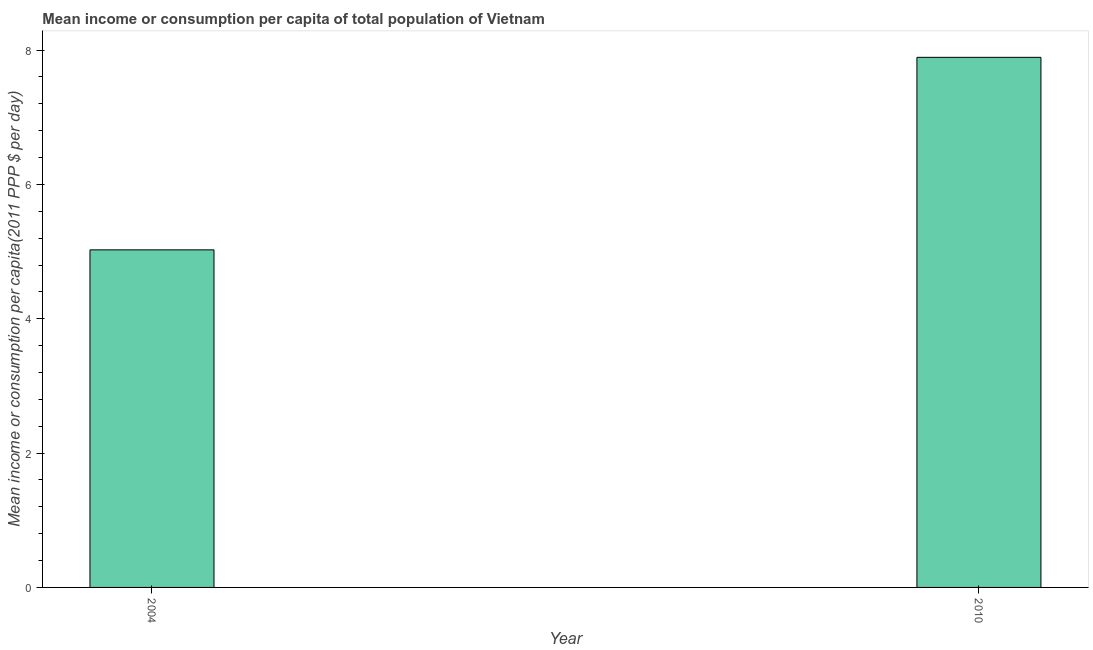What is the title of the graph?
Provide a succinct answer. Mean income or consumption per capita of total population of Vietnam. What is the label or title of the X-axis?
Offer a terse response. Year. What is the label or title of the Y-axis?
Your answer should be very brief. Mean income or consumption per capita(2011 PPP $ per day). What is the mean income or consumption in 2010?
Keep it short and to the point. 7.89. Across all years, what is the maximum mean income or consumption?
Ensure brevity in your answer.  7.89. Across all years, what is the minimum mean income or consumption?
Offer a terse response. 5.03. In which year was the mean income or consumption minimum?
Your answer should be very brief. 2004. What is the sum of the mean income or consumption?
Provide a succinct answer. 12.92. What is the difference between the mean income or consumption in 2004 and 2010?
Your response must be concise. -2.87. What is the average mean income or consumption per year?
Offer a terse response. 6.46. What is the median mean income or consumption?
Keep it short and to the point. 6.46. What is the ratio of the mean income or consumption in 2004 to that in 2010?
Make the answer very short. 0.64. Is the mean income or consumption in 2004 less than that in 2010?
Provide a short and direct response. Yes. In how many years, is the mean income or consumption greater than the average mean income or consumption taken over all years?
Your answer should be very brief. 1. How many bars are there?
Give a very brief answer. 2. Are all the bars in the graph horizontal?
Provide a succinct answer. No. How many years are there in the graph?
Make the answer very short. 2. Are the values on the major ticks of Y-axis written in scientific E-notation?
Offer a terse response. No. What is the Mean income or consumption per capita(2011 PPP $ per day) in 2004?
Your answer should be compact. 5.03. What is the Mean income or consumption per capita(2011 PPP $ per day) in 2010?
Provide a short and direct response. 7.89. What is the difference between the Mean income or consumption per capita(2011 PPP $ per day) in 2004 and 2010?
Offer a terse response. -2.87. What is the ratio of the Mean income or consumption per capita(2011 PPP $ per day) in 2004 to that in 2010?
Provide a short and direct response. 0.64. 